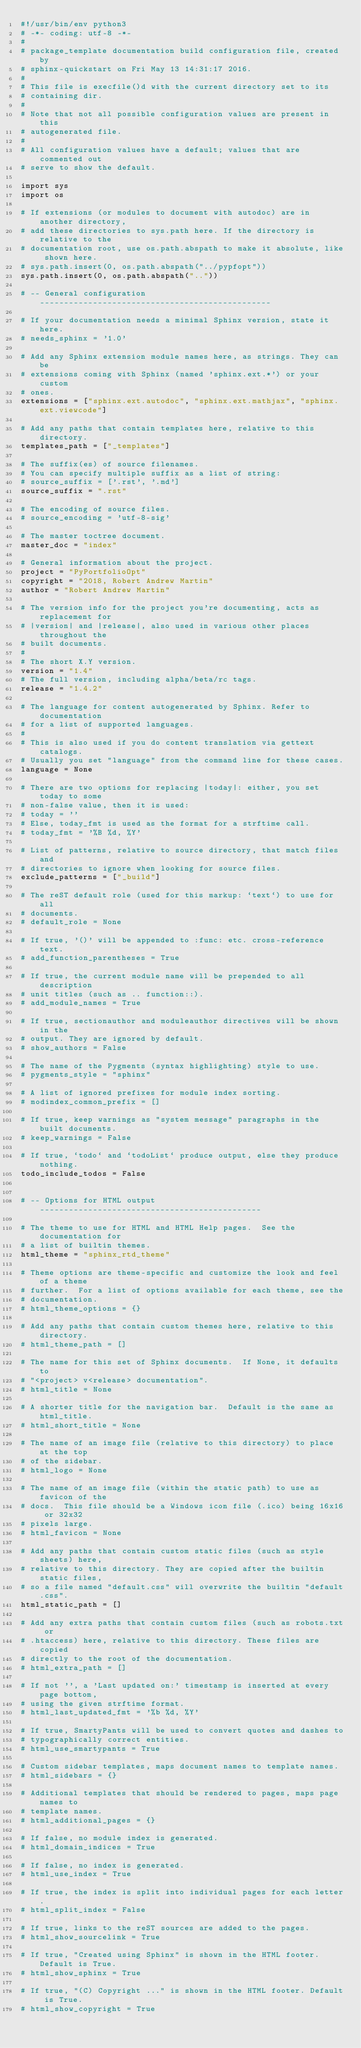Convert code to text. <code><loc_0><loc_0><loc_500><loc_500><_Python_>#!/usr/bin/env python3
# -*- coding: utf-8 -*-
#
# package_template documentation build configuration file, created by
# sphinx-quickstart on Fri May 13 14:31:17 2016.
#
# This file is execfile()d with the current directory set to its
# containing dir.
#
# Note that not all possible configuration values are present in this
# autogenerated file.
#
# All configuration values have a default; values that are commented out
# serve to show the default.

import sys
import os

# If extensions (or modules to document with autodoc) are in another directory,
# add these directories to sys.path here. If the directory is relative to the
# documentation root, use os.path.abspath to make it absolute, like shown here.
# sys.path.insert(0, os.path.abspath("../pypfopt"))
sys.path.insert(0, os.path.abspath(".."))

# -- General configuration ------------------------------------------------

# If your documentation needs a minimal Sphinx version, state it here.
# needs_sphinx = '1.0'

# Add any Sphinx extension module names here, as strings. They can be
# extensions coming with Sphinx (named 'sphinx.ext.*') or your custom
# ones.
extensions = ["sphinx.ext.autodoc", "sphinx.ext.mathjax", "sphinx.ext.viewcode"]

# Add any paths that contain templates here, relative to this directory.
templates_path = ["_templates"]

# The suffix(es) of source filenames.
# You can specify multiple suffix as a list of string:
# source_suffix = ['.rst', '.md']
source_suffix = ".rst"

# The encoding of source files.
# source_encoding = 'utf-8-sig'

# The master toctree document.
master_doc = "index"

# General information about the project.
project = "PyPortfolioOpt"
copyright = "2018, Robert Andrew Martin"
author = "Robert Andrew Martin"

# The version info for the project you're documenting, acts as replacement for
# |version| and |release|, also used in various other places throughout the
# built documents.
#
# The short X.Y version.
version = "1.4"
# The full version, including alpha/beta/rc tags.
release = "1.4.2"

# The language for content autogenerated by Sphinx. Refer to documentation
# for a list of supported languages.
#
# This is also used if you do content translation via gettext catalogs.
# Usually you set "language" from the command line for these cases.
language = None

# There are two options for replacing |today|: either, you set today to some
# non-false value, then it is used:
# today = ''
# Else, today_fmt is used as the format for a strftime call.
# today_fmt = '%B %d, %Y'

# List of patterns, relative to source directory, that match files and
# directories to ignore when looking for source files.
exclude_patterns = ["_build"]

# The reST default role (used for this markup: `text`) to use for all
# documents.
# default_role = None

# If true, '()' will be appended to :func: etc. cross-reference text.
# add_function_parentheses = True

# If true, the current module name will be prepended to all description
# unit titles (such as .. function::).
# add_module_names = True

# If true, sectionauthor and moduleauthor directives will be shown in the
# output. They are ignored by default.
# show_authors = False

# The name of the Pygments (syntax highlighting) style to use.
# pygments_style = "sphinx"

# A list of ignored prefixes for module index sorting.
# modindex_common_prefix = []

# If true, keep warnings as "system message" paragraphs in the built documents.
# keep_warnings = False

# If true, `todo` and `todoList` produce output, else they produce nothing.
todo_include_todos = False


# -- Options for HTML output ----------------------------------------------

# The theme to use for HTML and HTML Help pages.  See the documentation for
# a list of builtin themes.
html_theme = "sphinx_rtd_theme"

# Theme options are theme-specific and customize the look and feel of a theme
# further.  For a list of options available for each theme, see the
# documentation.
# html_theme_options = {}

# Add any paths that contain custom themes here, relative to this directory.
# html_theme_path = []

# The name for this set of Sphinx documents.  If None, it defaults to
# "<project> v<release> documentation".
# html_title = None

# A shorter title for the navigation bar.  Default is the same as html_title.
# html_short_title = None

# The name of an image file (relative to this directory) to place at the top
# of the sidebar.
# html_logo = None

# The name of an image file (within the static path) to use as favicon of the
# docs.  This file should be a Windows icon file (.ico) being 16x16 or 32x32
# pixels large.
# html_favicon = None

# Add any paths that contain custom static files (such as style sheets) here,
# relative to this directory. They are copied after the builtin static files,
# so a file named "default.css" will overwrite the builtin "default.css".
html_static_path = []

# Add any extra paths that contain custom files (such as robots.txt or
# .htaccess) here, relative to this directory. These files are copied
# directly to the root of the documentation.
# html_extra_path = []

# If not '', a 'Last updated on:' timestamp is inserted at every page bottom,
# using the given strftime format.
# html_last_updated_fmt = '%b %d, %Y'

# If true, SmartyPants will be used to convert quotes and dashes to
# typographically correct entities.
# html_use_smartypants = True

# Custom sidebar templates, maps document names to template names.
# html_sidebars = {}

# Additional templates that should be rendered to pages, maps page names to
# template names.
# html_additional_pages = {}

# If false, no module index is generated.
# html_domain_indices = True

# If false, no index is generated.
# html_use_index = True

# If true, the index is split into individual pages for each letter.
# html_split_index = False

# If true, links to the reST sources are added to the pages.
# html_show_sourcelink = True

# If true, "Created using Sphinx" is shown in the HTML footer. Default is True.
# html_show_sphinx = True

# If true, "(C) Copyright ..." is shown in the HTML footer. Default is True.
# html_show_copyright = True
</code> 